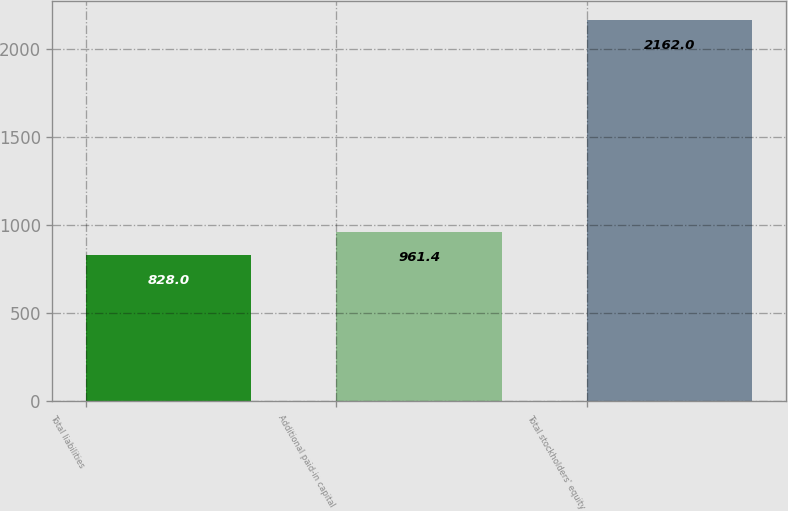Convert chart. <chart><loc_0><loc_0><loc_500><loc_500><bar_chart><fcel>Total liabilities<fcel>Additional paid-in capital<fcel>Total stockholders' equity<nl><fcel>828<fcel>961.4<fcel>2162<nl></chart> 